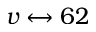Convert formula to latex. <formula><loc_0><loc_0><loc_500><loc_500>v \leftrightarrow 6 2</formula> 